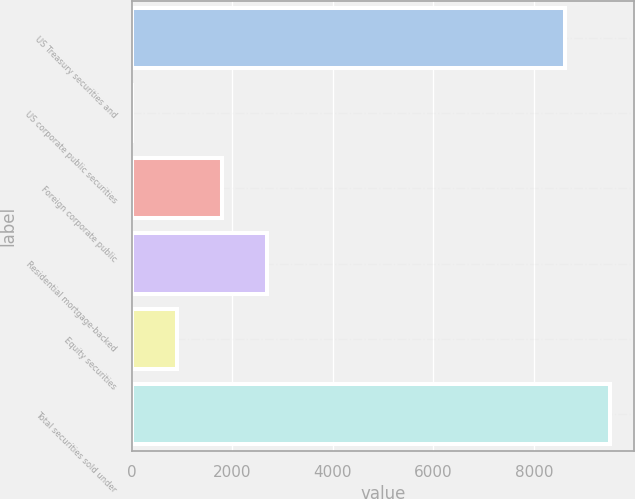<chart> <loc_0><loc_0><loc_500><loc_500><bar_chart><fcel>US Treasury securities and<fcel>US corporate public securities<fcel>Foreign corporate public<fcel>Residential mortgage-backed<fcel>Equity securities<fcel>Total securities sold under<nl><fcel>8614<fcel>2.42<fcel>1793.14<fcel>2688.5<fcel>897.78<fcel>9509.36<nl></chart> 